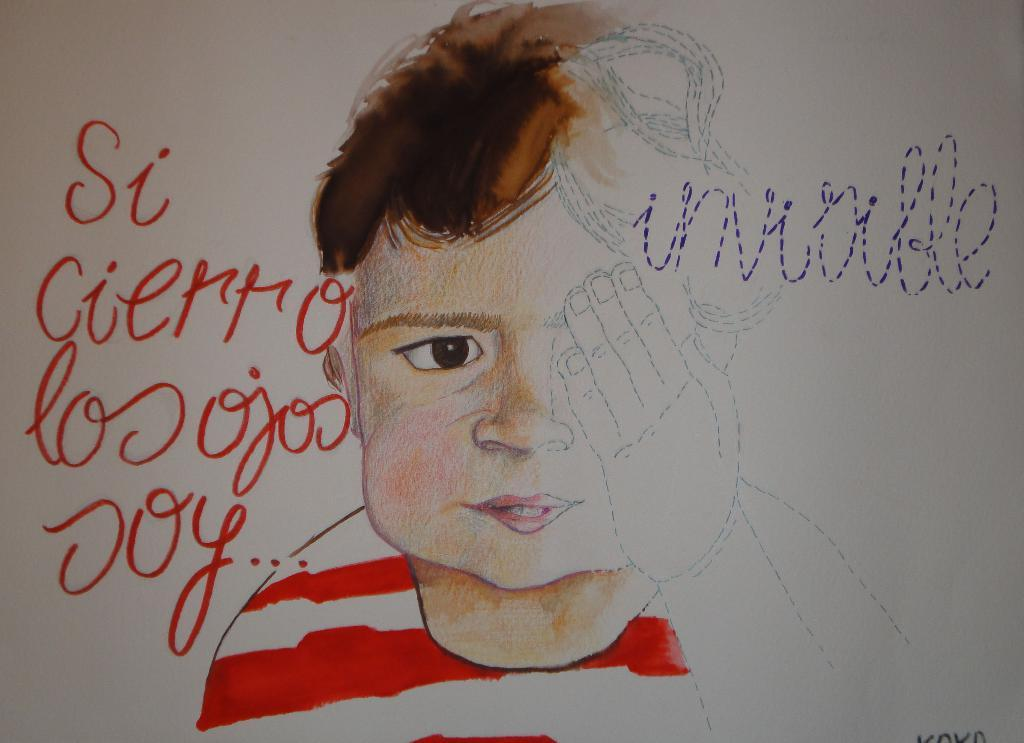What type of artwork is shown in the image? The image is a painting. Who or what is depicted in the painting? There is a person depicted in the painting. Where can text be found in the painting? There is text on the left side of the painting and on the right side of the painting. What type of reward is the person holding in the painting? There is no reward visible in the painting; it only depicts a person and text on both sides. 